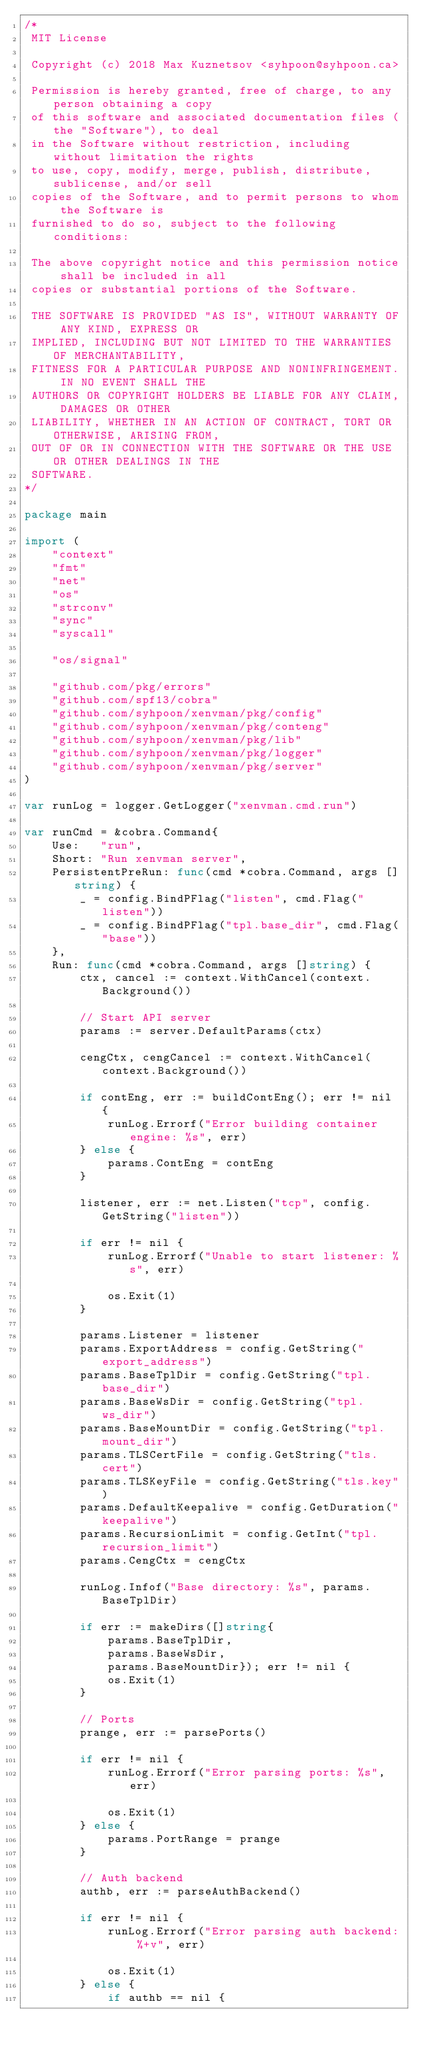<code> <loc_0><loc_0><loc_500><loc_500><_Go_>/*
 MIT License

 Copyright (c) 2018 Max Kuznetsov <syhpoon@syhpoon.ca>

 Permission is hereby granted, free of charge, to any person obtaining a copy
 of this software and associated documentation files (the "Software"), to deal
 in the Software without restriction, including without limitation the rights
 to use, copy, modify, merge, publish, distribute, sublicense, and/or sell
 copies of the Software, and to permit persons to whom the Software is
 furnished to do so, subject to the following conditions:

 The above copyright notice and this permission notice shall be included in all
 copies or substantial portions of the Software.

 THE SOFTWARE IS PROVIDED "AS IS", WITHOUT WARRANTY OF ANY KIND, EXPRESS OR
 IMPLIED, INCLUDING BUT NOT LIMITED TO THE WARRANTIES OF MERCHANTABILITY,
 FITNESS FOR A PARTICULAR PURPOSE AND NONINFRINGEMENT. IN NO EVENT SHALL THE
 AUTHORS OR COPYRIGHT HOLDERS BE LIABLE FOR ANY CLAIM, DAMAGES OR OTHER
 LIABILITY, WHETHER IN AN ACTION OF CONTRACT, TORT OR OTHERWISE, ARISING FROM,
 OUT OF OR IN CONNECTION WITH THE SOFTWARE OR THE USE OR OTHER DEALINGS IN THE
 SOFTWARE.
*/

package main

import (
	"context"
	"fmt"
	"net"
	"os"
	"strconv"
	"sync"
	"syscall"

	"os/signal"

	"github.com/pkg/errors"
	"github.com/spf13/cobra"
	"github.com/syhpoon/xenvman/pkg/config"
	"github.com/syhpoon/xenvman/pkg/conteng"
	"github.com/syhpoon/xenvman/pkg/lib"
	"github.com/syhpoon/xenvman/pkg/logger"
	"github.com/syhpoon/xenvman/pkg/server"
)

var runLog = logger.GetLogger("xenvman.cmd.run")

var runCmd = &cobra.Command{
	Use:   "run",
	Short: "Run xenvman server",
	PersistentPreRun: func(cmd *cobra.Command, args []string) {
		_ = config.BindPFlag("listen", cmd.Flag("listen"))
		_ = config.BindPFlag("tpl.base_dir", cmd.Flag("base"))
	},
	Run: func(cmd *cobra.Command, args []string) {
		ctx, cancel := context.WithCancel(context.Background())

		// Start API server
		params := server.DefaultParams(ctx)

		cengCtx, cengCancel := context.WithCancel(context.Background())

		if contEng, err := buildContEng(); err != nil {
			runLog.Errorf("Error building container engine: %s", err)
		} else {
			params.ContEng = contEng
		}

		listener, err := net.Listen("tcp", config.GetString("listen"))

		if err != nil {
			runLog.Errorf("Unable to start listener: %s", err)

			os.Exit(1)
		}

		params.Listener = listener
		params.ExportAddress = config.GetString("export_address")
		params.BaseTplDir = config.GetString("tpl.base_dir")
		params.BaseWsDir = config.GetString("tpl.ws_dir")
		params.BaseMountDir = config.GetString("tpl.mount_dir")
		params.TLSCertFile = config.GetString("tls.cert")
		params.TLSKeyFile = config.GetString("tls.key")
		params.DefaultKeepalive = config.GetDuration("keepalive")
		params.RecursionLimit = config.GetInt("tpl.recursion_limit")
		params.CengCtx = cengCtx

		runLog.Infof("Base directory: %s", params.BaseTplDir)

		if err := makeDirs([]string{
			params.BaseTplDir,
			params.BaseWsDir,
			params.BaseMountDir}); err != nil {
			os.Exit(1)
		}

		// Ports
		prange, err := parsePorts()

		if err != nil {
			runLog.Errorf("Error parsing ports: %s", err)

			os.Exit(1)
		} else {
			params.PortRange = prange
		}

		// Auth backend
		authb, err := parseAuthBackend()

		if err != nil {
			runLog.Errorf("Error parsing auth backend: %+v", err)

			os.Exit(1)
		} else {
			if authb == nil {</code> 